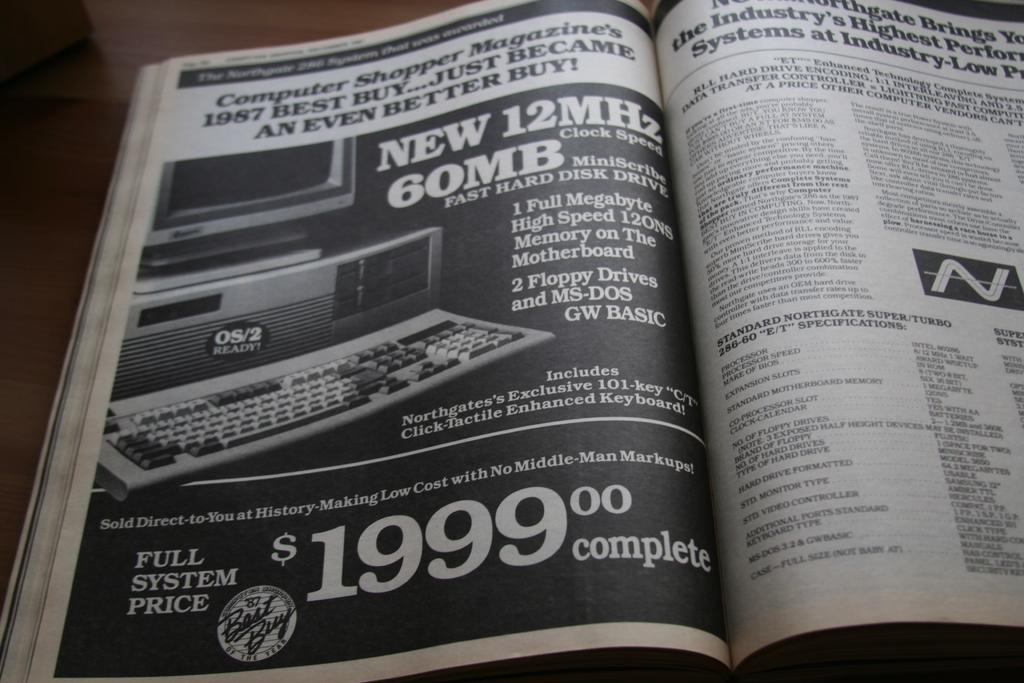<image>
Give a short and clear explanation of the subsequent image. An old black and white magazine open to a page advertising a computer for $1999. 